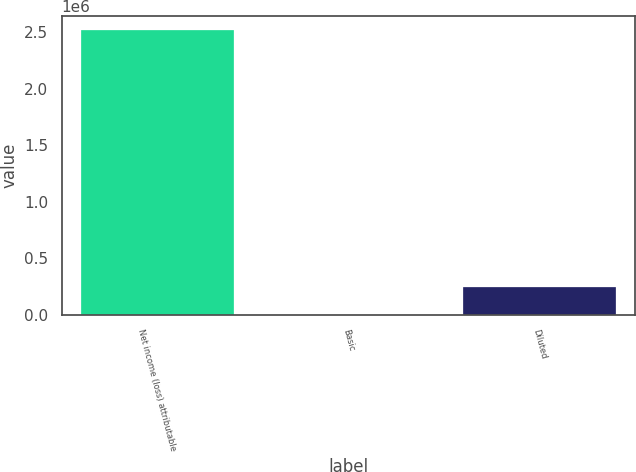Convert chart to OTSL. <chart><loc_0><loc_0><loc_500><loc_500><bar_chart><fcel>Net income (loss) attributable<fcel>Basic<fcel>Diluted<nl><fcel>2.51776e+06<fcel>8.8<fcel>251784<nl></chart> 